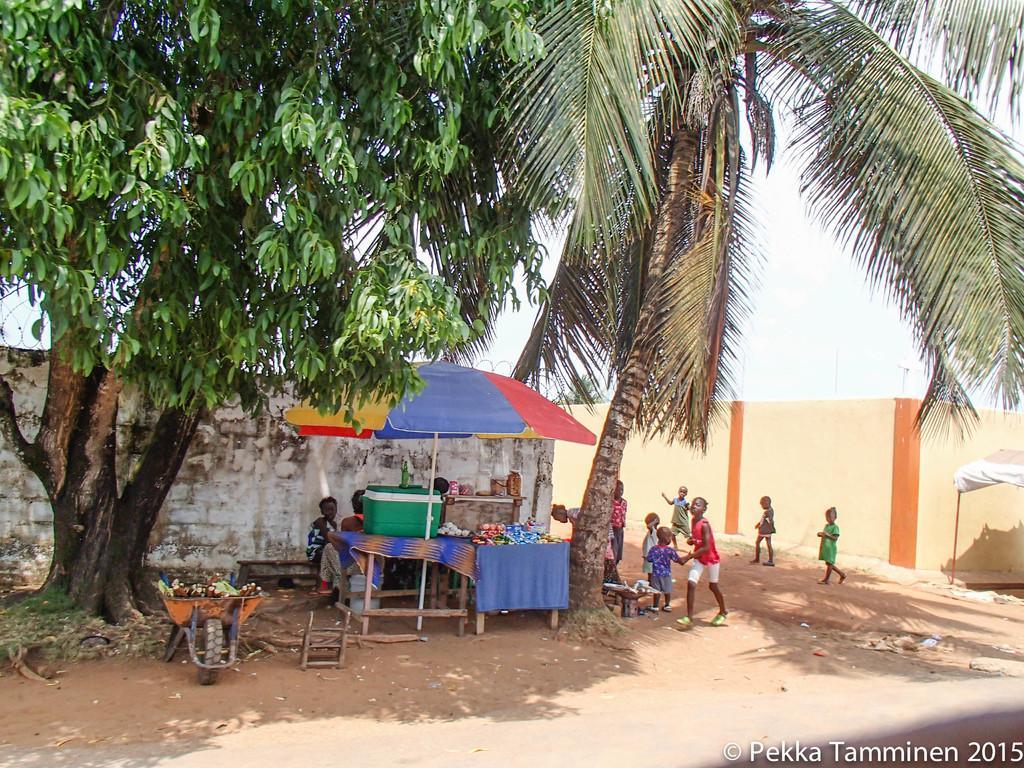Please provide a concise description of this image. In this picture we can observe trees. There is an umbrella. We can observe a table and some boxes on the table under this umbrella. There are some children playing on the ground. We can observe white and cream color walls. In the background there is a sky. On the right side we can observe a text in this picture. 